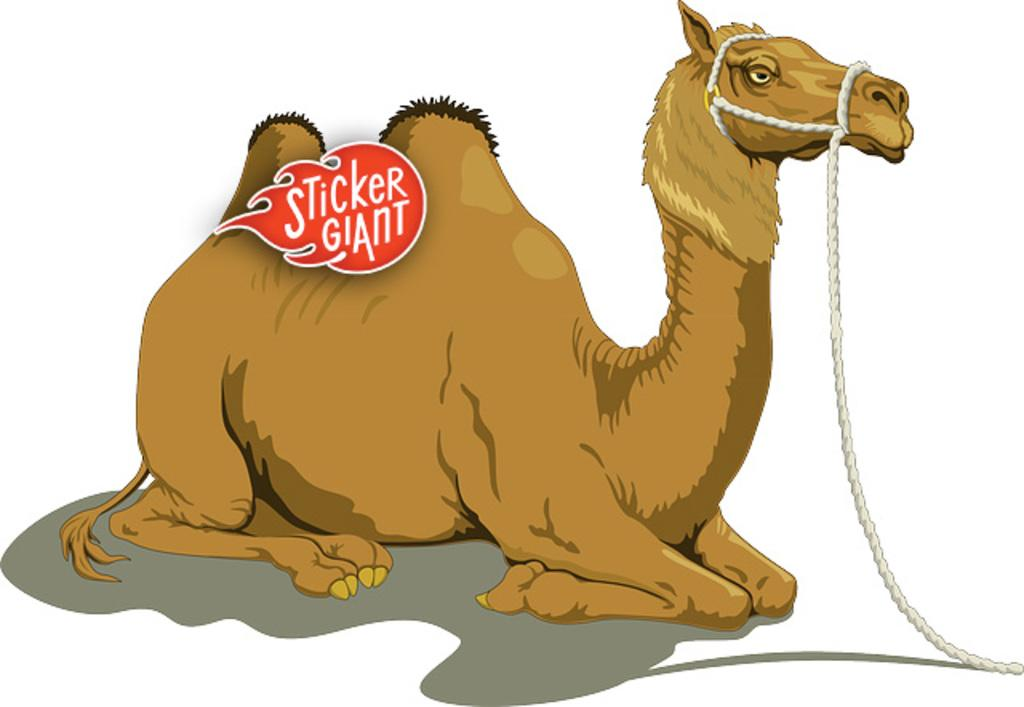What type of media is the image? The image is an animation. What animal is in the center of the image? There is a camel in the center of the image. What is present in the foreground of the image? There is a logo in the foreground. What object can be seen on the right side of the image? There is a rope on the right side of the image. What color is the background of the image? The background of the image is white. How many geese are flying in the image? There are no geese present in the image. What type of shock can be seen in the image? There is no shock present in the image. 